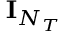Convert formula to latex. <formula><loc_0><loc_0><loc_500><loc_500>{ I } _ { N _ { T } }</formula> 